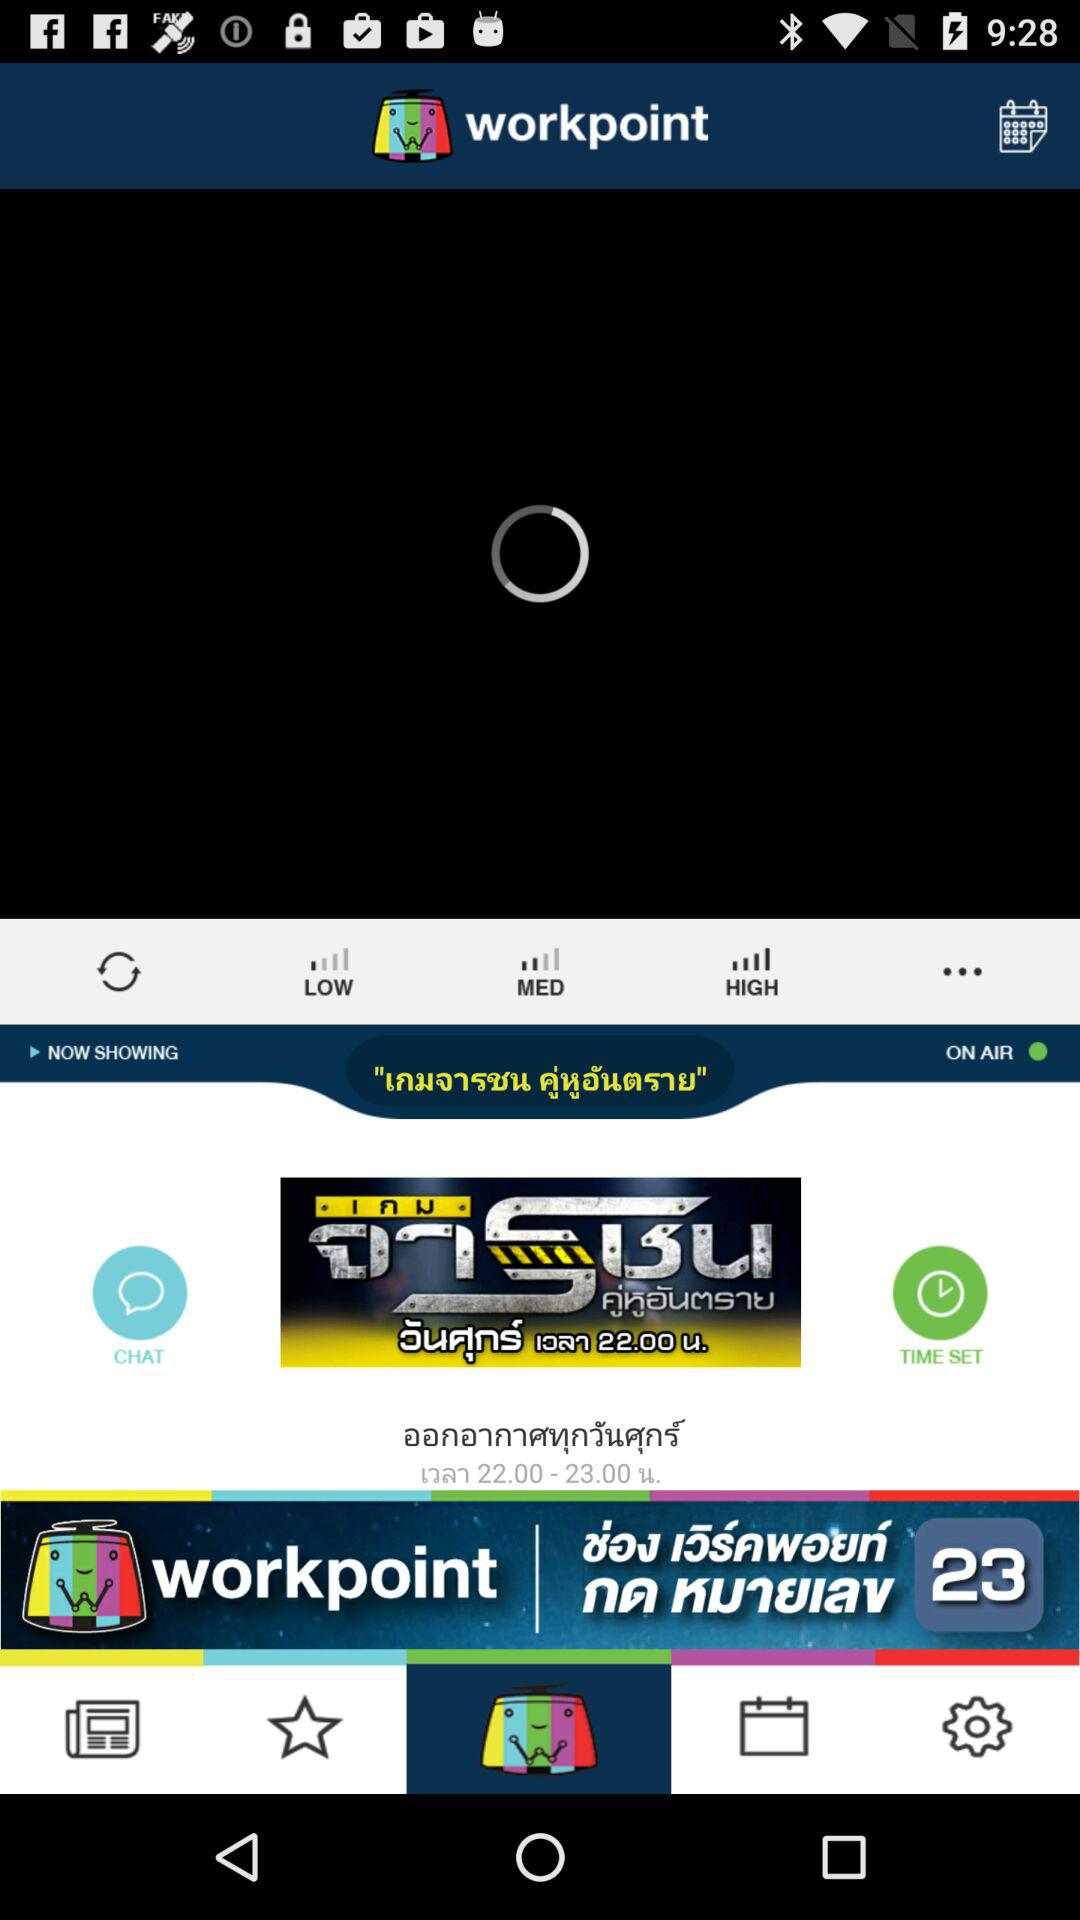Which tab is selected? The selected tab is "workpoint". 